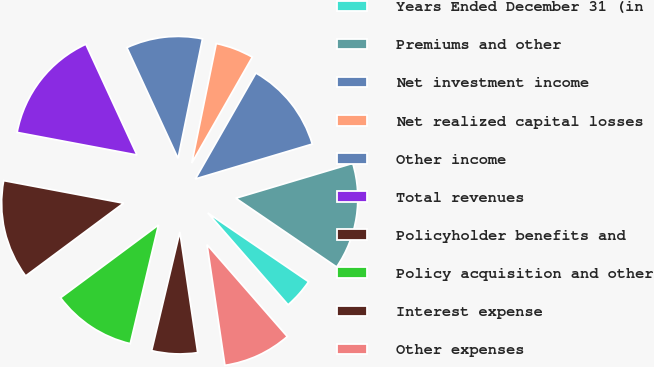<chart> <loc_0><loc_0><loc_500><loc_500><pie_chart><fcel>Years Ended December 31 (in<fcel>Premiums and other<fcel>Net investment income<fcel>Net realized capital losses<fcel>Other income<fcel>Total revenues<fcel>Policyholder benefits and<fcel>Policy acquisition and other<fcel>Interest expense<fcel>Other expenses<nl><fcel>4.04%<fcel>14.14%<fcel>12.12%<fcel>5.05%<fcel>10.1%<fcel>15.15%<fcel>13.13%<fcel>11.11%<fcel>6.06%<fcel>9.09%<nl></chart> 